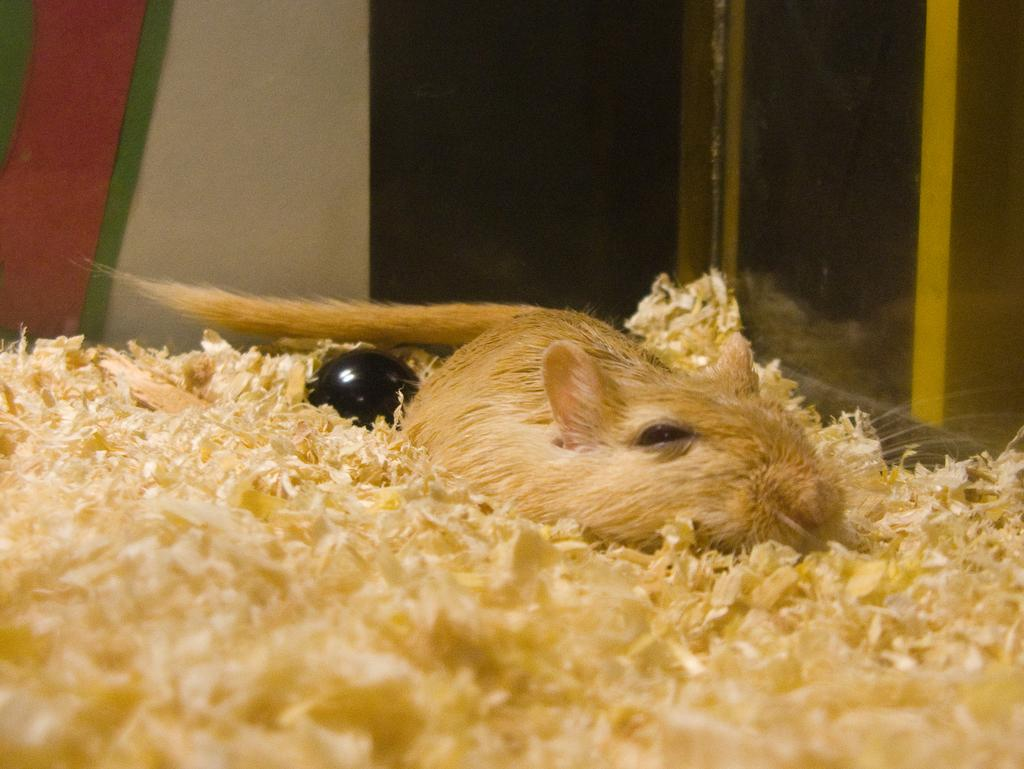What type of animal is in the image? The type of animal cannot be determined from the provided facts. How is the animal contained in the image? The animal is kept in a glass box. What can be seen around the animal in the image? There is waste material around the animal. What is the name of the animal in the image? The name of the animal cannot be determined from the provided facts. Is there any coal present in the image? There is no mention of coal in the provided facts, so it cannot be determined if coal is present in the image. 